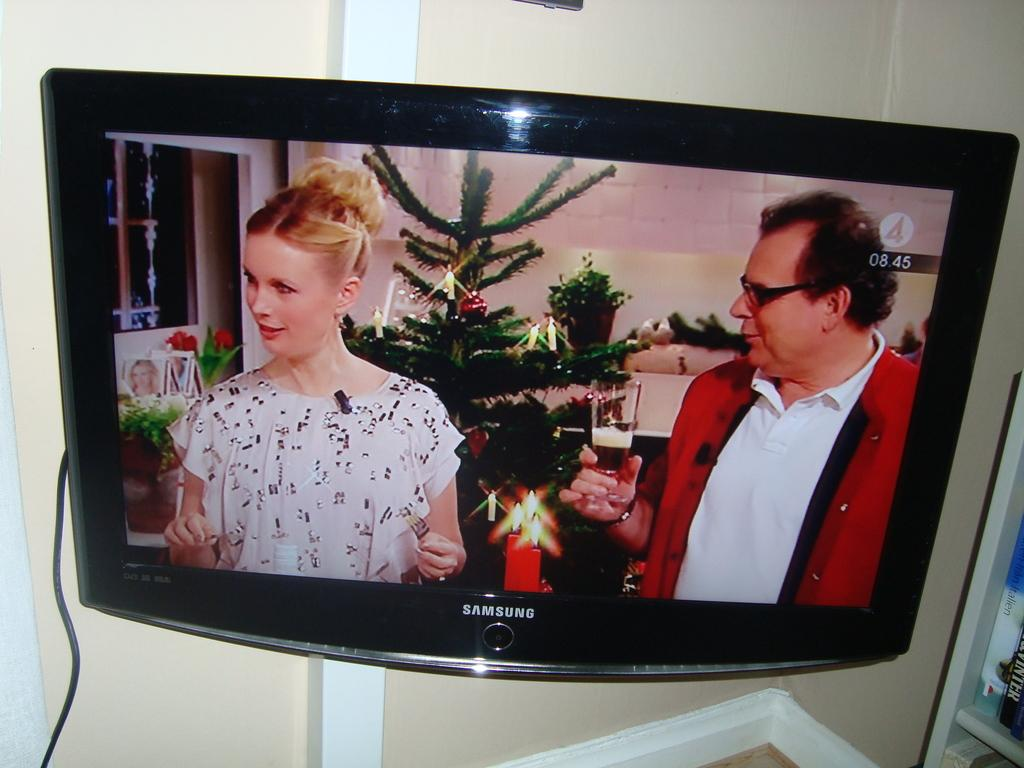<image>
Write a terse but informative summary of the picture. A samsung branded television is displaying a man and a woman standing in front of a christmas tree. 